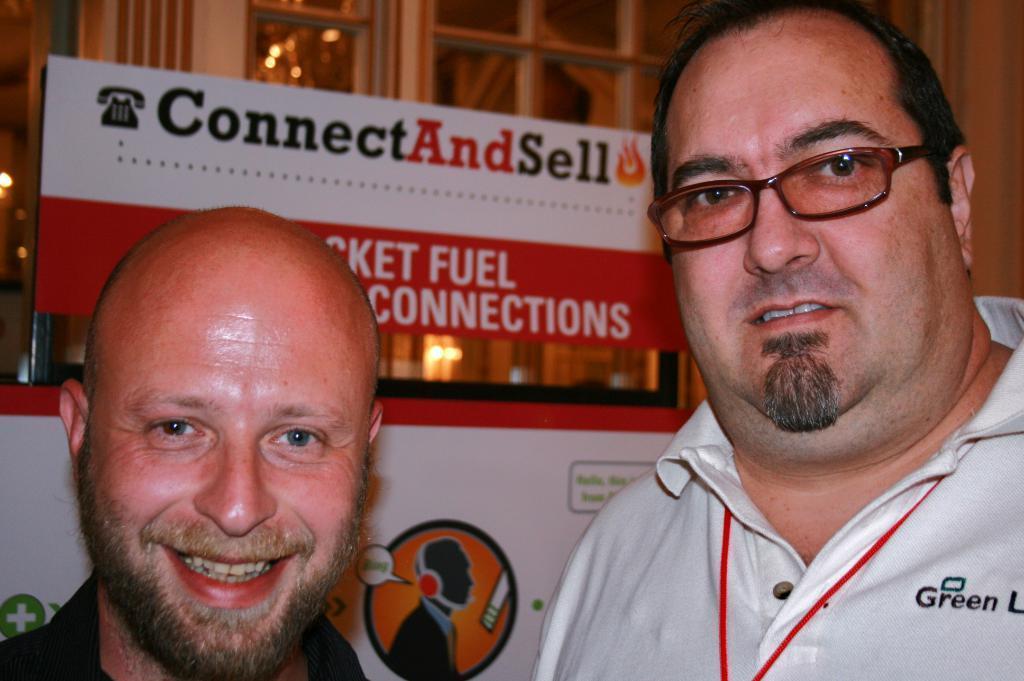Please provide a concise description of this image. This image is taken indoors. In the background there are two boards with text on them. There is a wall and there is a door. On the left side of the image there is a man and he is with a smiling face. On the right side of the image there is a man. 